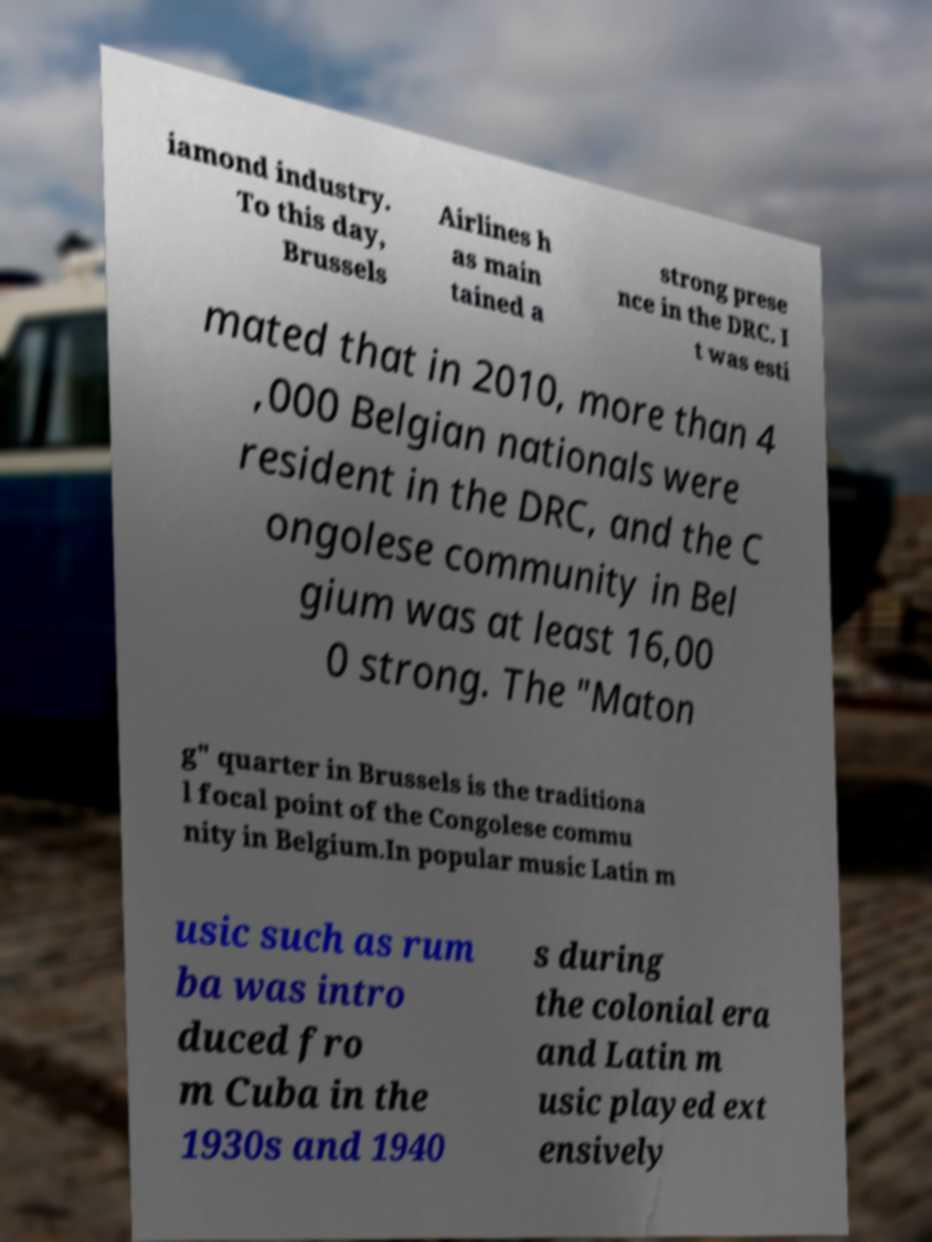Please read and relay the text visible in this image. What does it say? iamond industry. To this day, Brussels Airlines h as main tained a strong prese nce in the DRC. I t was esti mated that in 2010, more than 4 ,000 Belgian nationals were resident in the DRC, and the C ongolese community in Bel gium was at least 16,00 0 strong. The "Maton g" quarter in Brussels is the traditiona l focal point of the Congolese commu nity in Belgium.In popular music Latin m usic such as rum ba was intro duced fro m Cuba in the 1930s and 1940 s during the colonial era and Latin m usic played ext ensively 